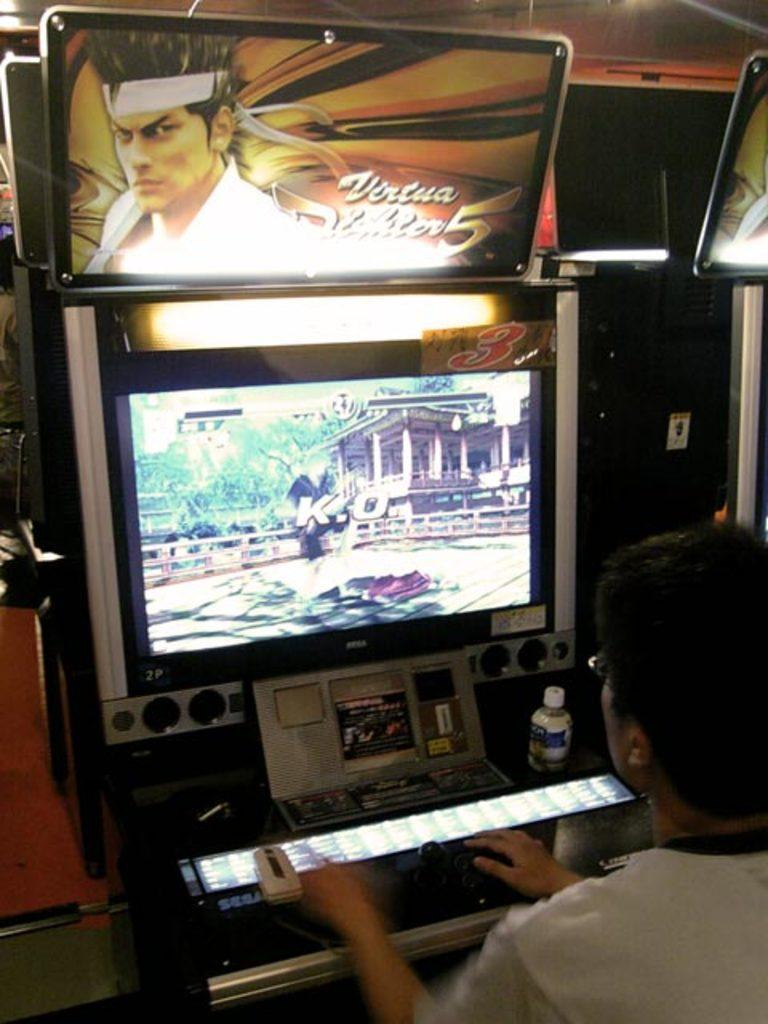<image>
Render a clear and concise summary of the photo. a person playing a game with the number 5 on it 